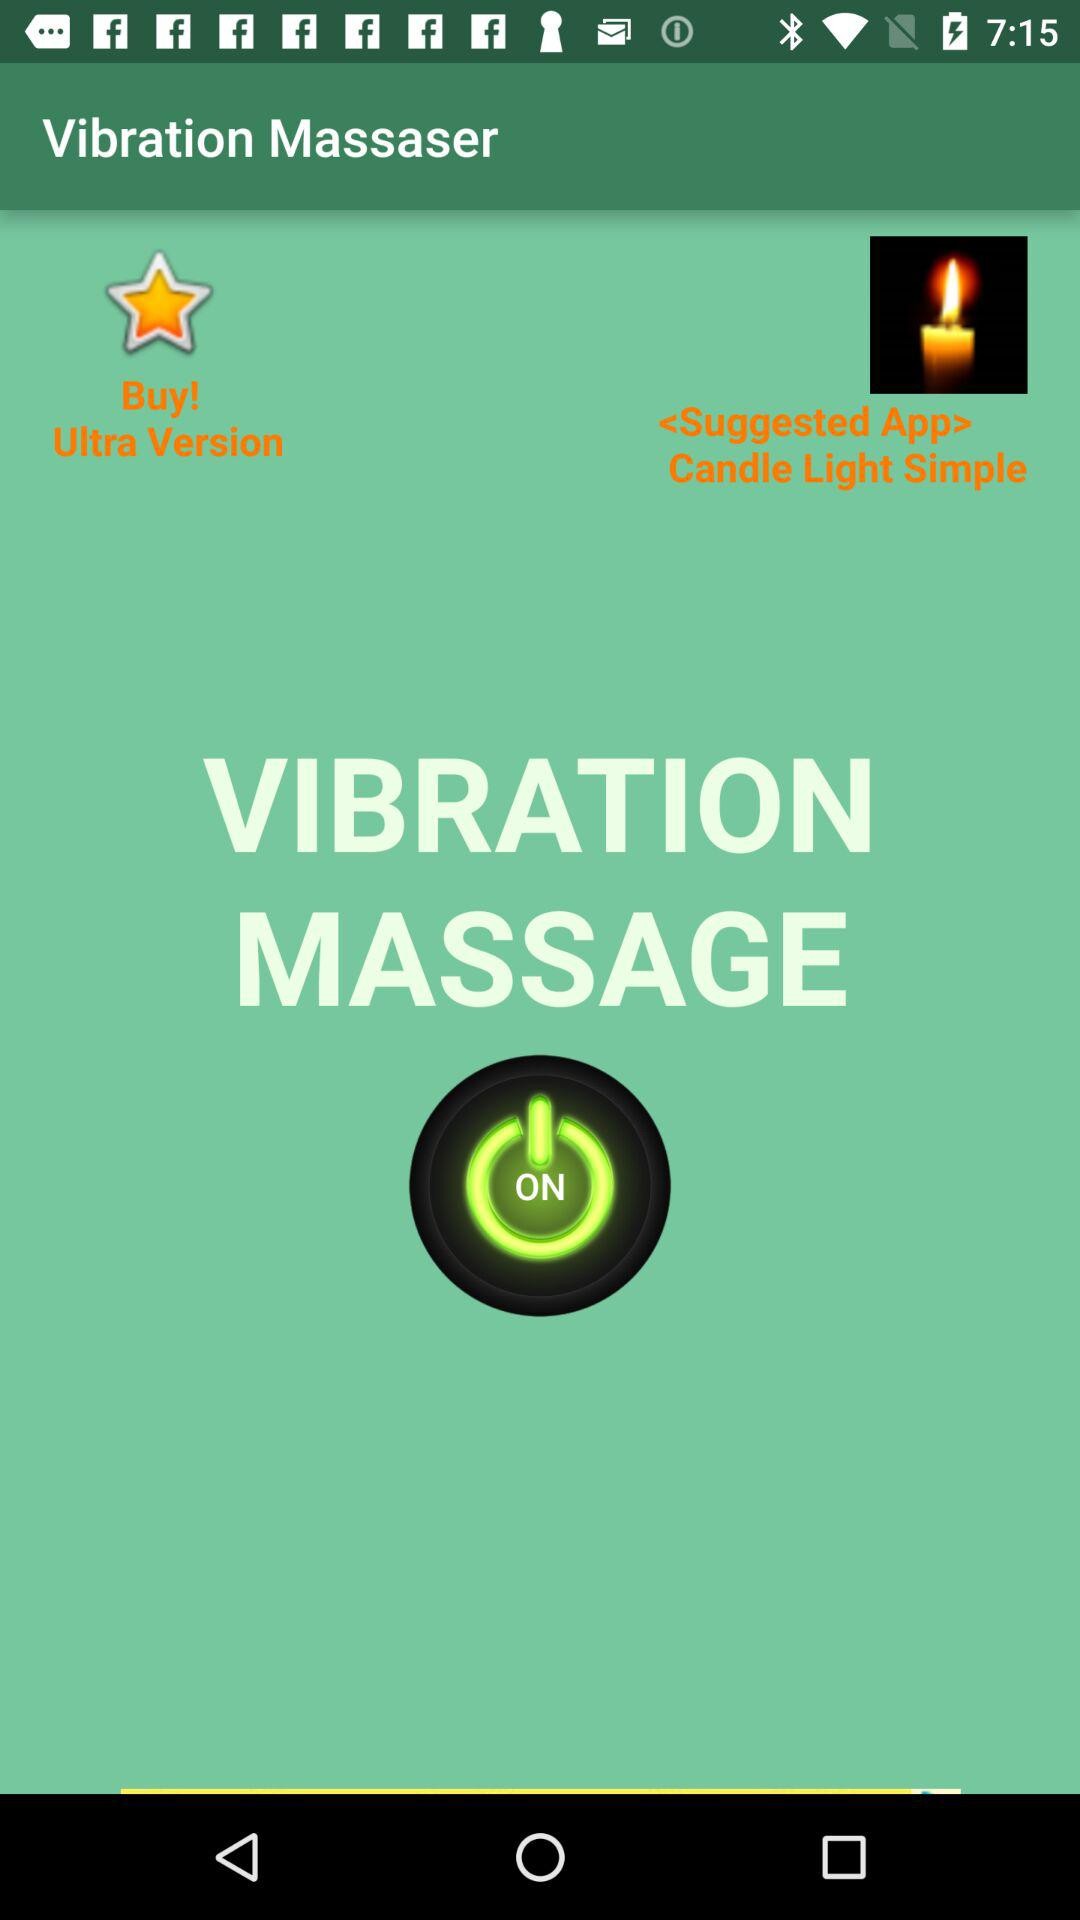Is "VIBRATION MASSAGE" on or off? "VIBRATION MASSAGE" is on. 